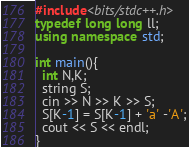<code> <loc_0><loc_0><loc_500><loc_500><_C++_>#include<bits/stdc++.h>
typedef long long ll;
using namespace std;

int main(){
  int N,K;
  string S;
  cin >> N >> K >> S;
  S[K-1] = S[K-1] + 'a' -'A';
  cout << S << endl;
}</code> 